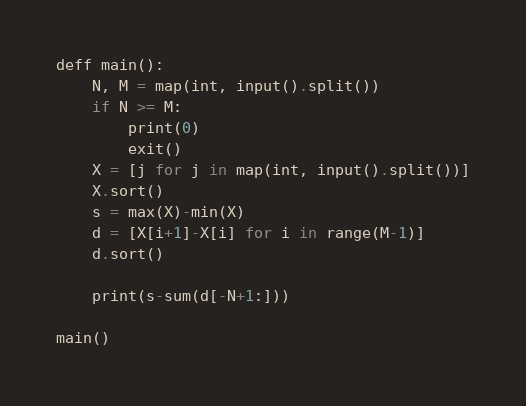Convert code to text. <code><loc_0><loc_0><loc_500><loc_500><_Python_>deff main():
    N, M = map(int, input().split())
    if N >= M:
        print(0)
        exit()
    X = [j for j in map(int, input().split())]
    X.sort()
    s = max(X)-min(X)
    d = [X[i+1]-X[i] for i in range(M-1)]
    d.sort()

    print(s-sum(d[-N+1:]))

main()
</code> 